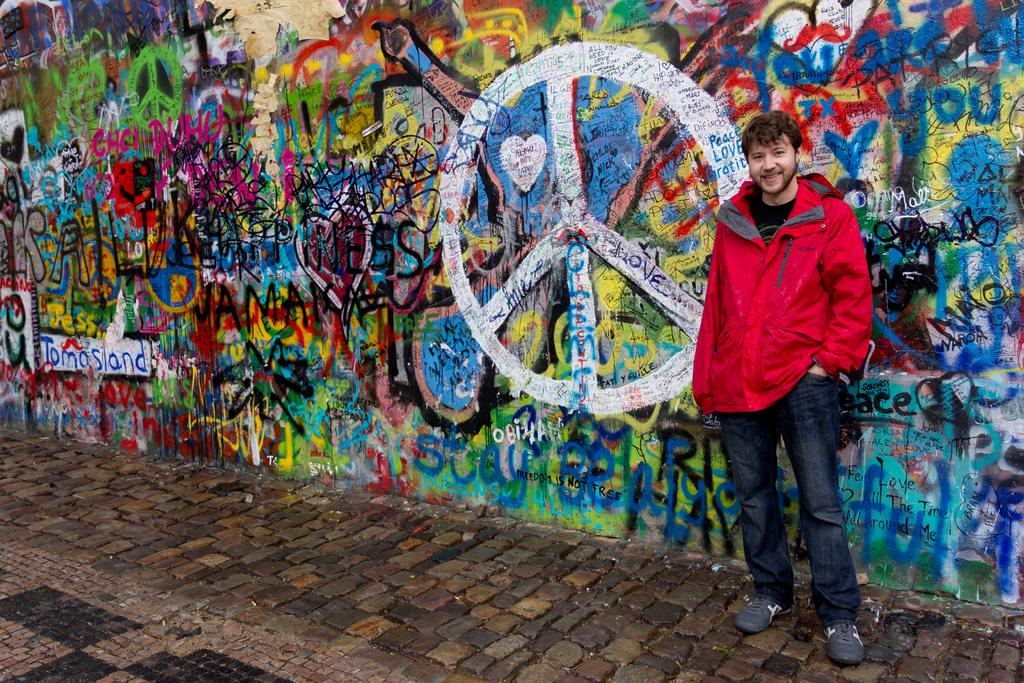What is the main subject of the image? There is a person standing in the image. What can be seen in the background of the image? There is a wall in the background of the image. What is on the wall? There is graffiti on the wall. What is at the bottom of the image? There is a walkway at the bottom of the image. What type of tank is visible in the image? There is no tank present in the image. What role does the air play in the image? The air is not a subject or object in the image, so it does not play a role. 